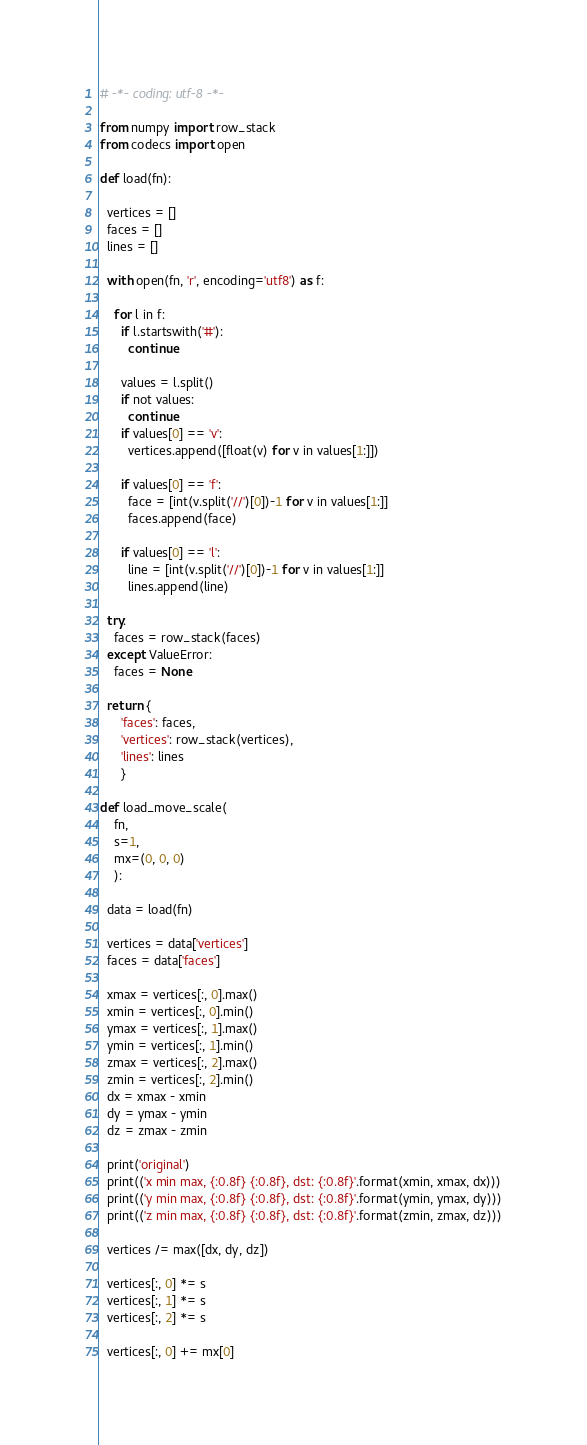Convert code to text. <code><loc_0><loc_0><loc_500><loc_500><_Python_># -*- coding: utf-8 -*-

from numpy import row_stack
from codecs import open

def load(fn):

  vertices = []
  faces = []
  lines = []

  with open(fn, 'r', encoding='utf8') as f:

    for l in f:
      if l.startswith('#'):
        continue

      values = l.split()
      if not values:
        continue
      if values[0] == 'v':
        vertices.append([float(v) for v in values[1:]])

      if values[0] == 'f':
        face = [int(v.split('//')[0])-1 for v in values[1:]]
        faces.append(face)

      if values[0] == 'l':
        line = [int(v.split('//')[0])-1 for v in values[1:]]
        lines.append(line)

  try:
    faces = row_stack(faces)
  except ValueError:
    faces = None

  return {
      'faces': faces,
      'vertices': row_stack(vertices),
      'lines': lines
      }

def load_move_scale(
    fn,
    s=1,
    mx=(0, 0, 0)
    ):

  data = load(fn)

  vertices = data['vertices']
  faces = data['faces']

  xmax = vertices[:, 0].max()
  xmin = vertices[:, 0].min()
  ymax = vertices[:, 1].max()
  ymin = vertices[:, 1].min()
  zmax = vertices[:, 2].max()
  zmin = vertices[:, 2].min()
  dx = xmax - xmin
  dy = ymax - ymin
  dz = zmax - zmin

  print('original')
  print(('x min max, {:0.8f} {:0.8f}, dst: {:0.8f}'.format(xmin, xmax, dx)))
  print(('y min max, {:0.8f} {:0.8f}, dst: {:0.8f}'.format(ymin, ymax, dy)))
  print(('z min max, {:0.8f} {:0.8f}, dst: {:0.8f}'.format(zmin, zmax, dz)))

  vertices /= max([dx, dy, dz])

  vertices[:, 0] *= s
  vertices[:, 1] *= s
  vertices[:, 2] *= s

  vertices[:, 0] += mx[0]</code> 